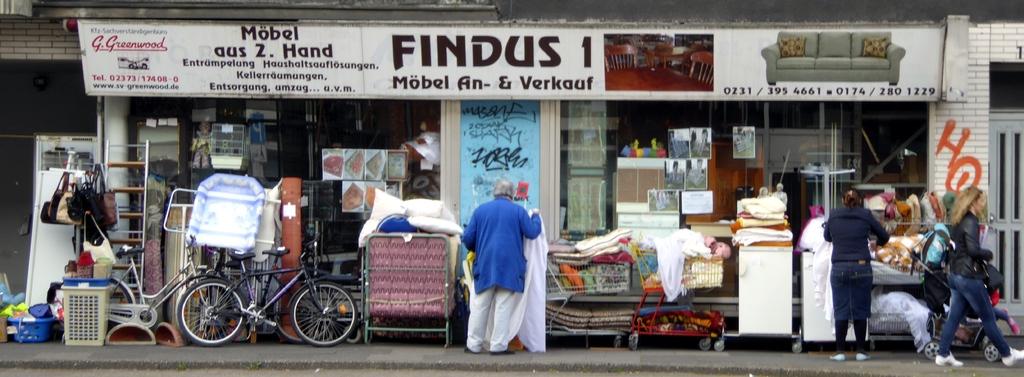What is the name of the store?
Your response must be concise. Findus. 